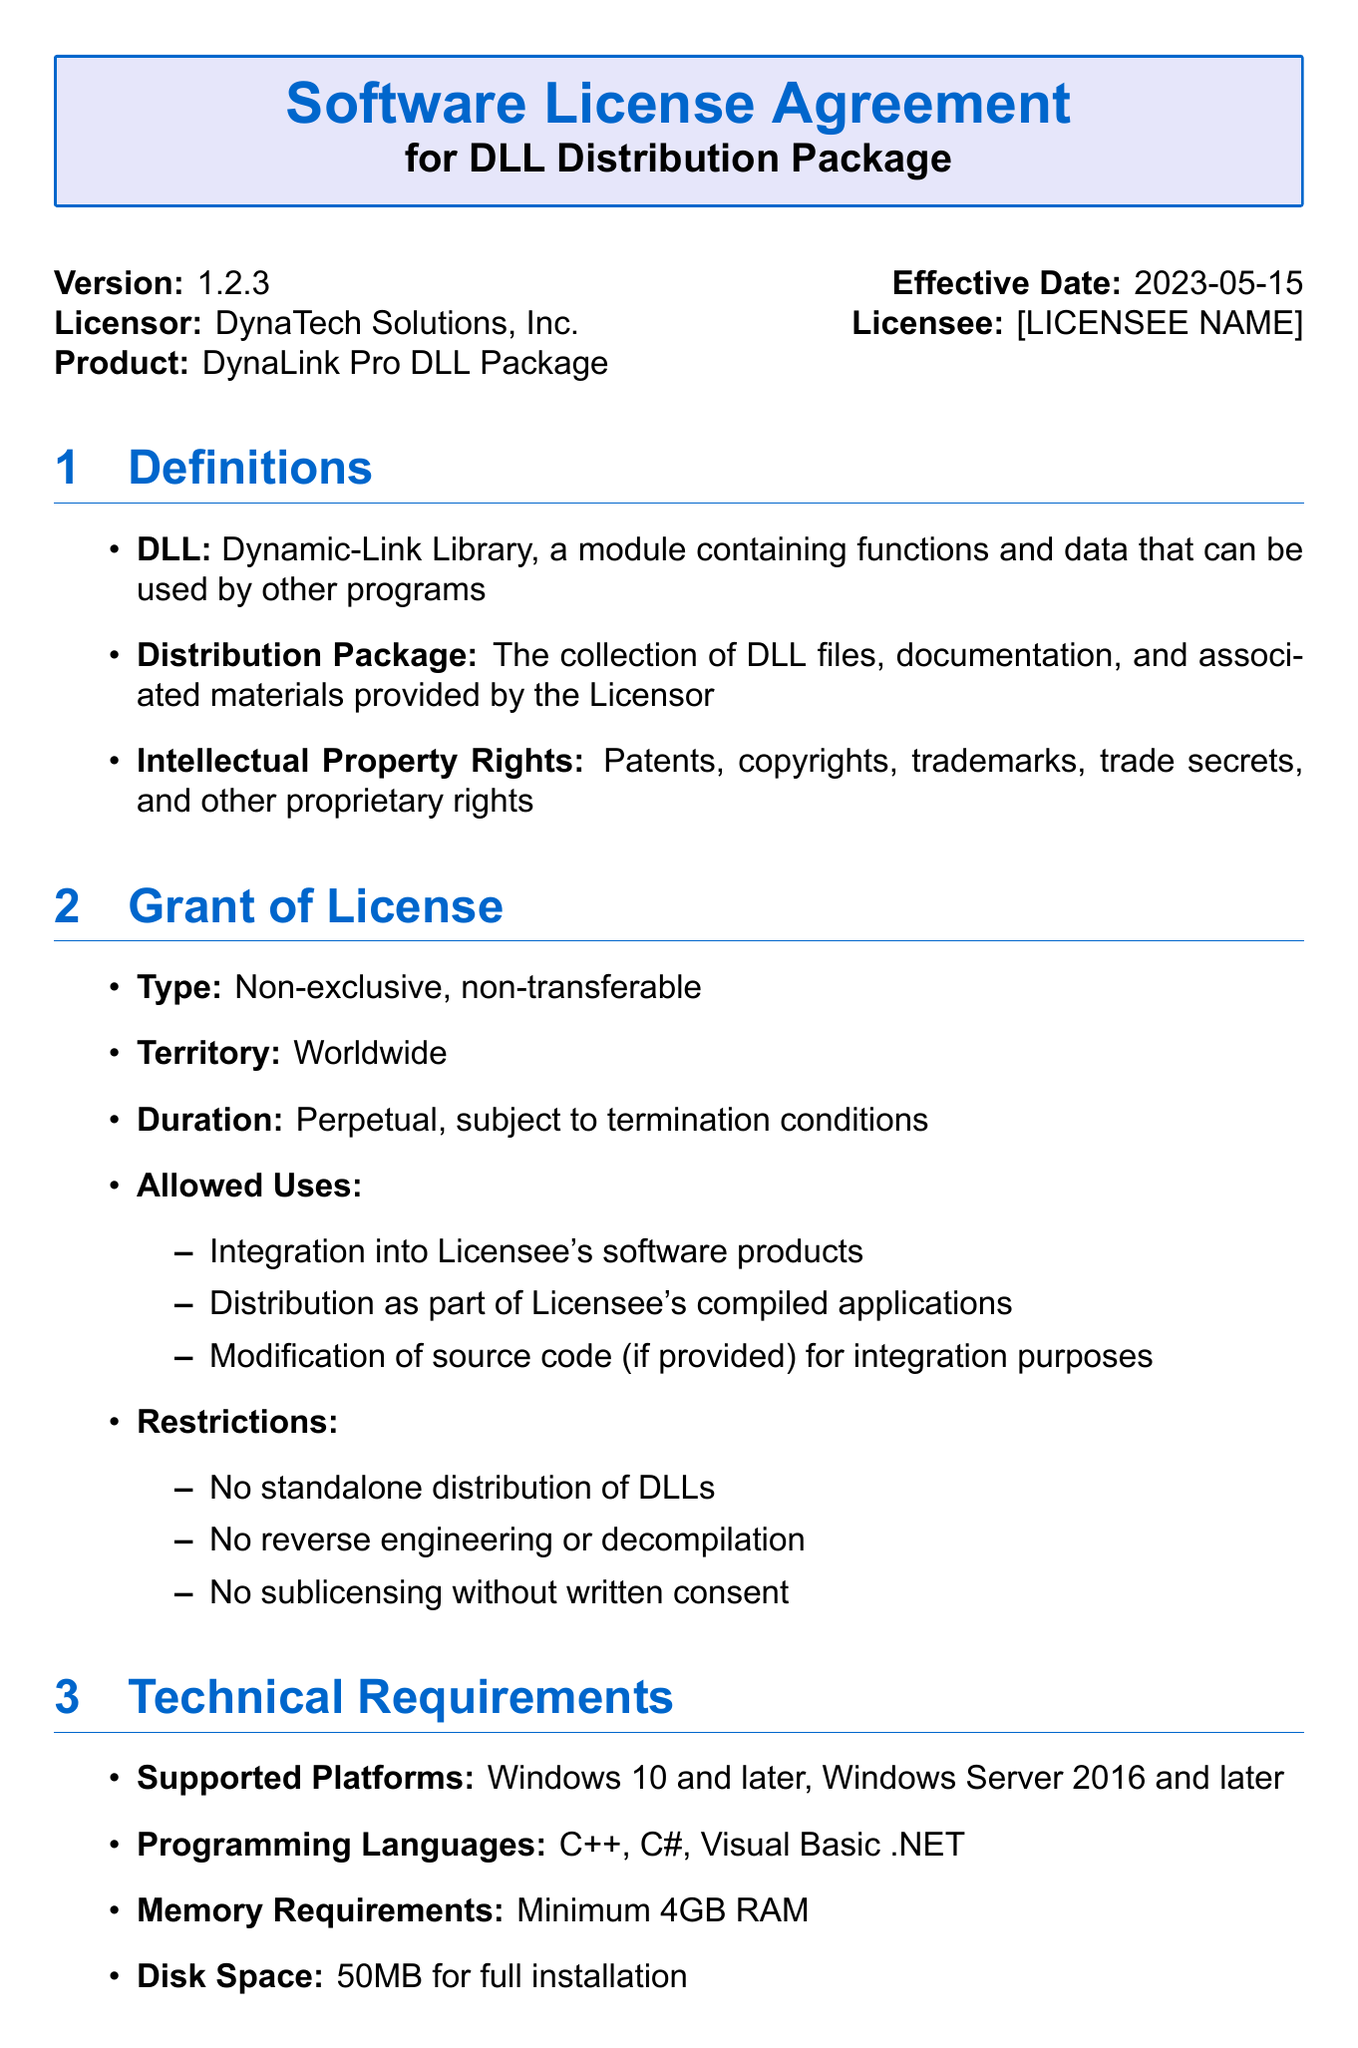What is the version of the license agreement? The version of the license agreement is mentioned towards the beginning of the document.
Answer: 1.2.3 What is the effective date of the agreement? The effective date is specified shortly after the version in the document.
Answer: 2023-05-15 Who is the licensor? The licensor is stated prominently at the start of the document.
Answer: DynaTech Solutions, Inc What are the allowed uses of the DLL? The allowed uses are detailed in the Grant of License section.
Answer: Integration into Licensee's software products, Distribution as part of Licensee's compiled applications, Modification of source code What are the restrictions placed on the licensee? The restrictions are listed under the Grant of License section, stating what the licensee cannot do.
Answer: No standalone distribution of DLLs, No reverse engineering or decompilation, No sublicensing without written consent What is the price of the Standard License? The price for this license type is clearly outlined in the Fees section of the document.
Answer: $2,500 per year How often are updates provided? The updates frequency is mentioned in the Maintenance and Support section.
Answer: Quarterly What happens upon termination by the licensee? The consequences of termination by the licensee are specified in the Termination section.
Answer: Cease all use of DLL package, Return or destroy all copies of DLL package, Certify compliance with termination obligations What is the governing law stated in the document? The governing law for this license agreement is mentioned in the governing law section.
Answer: State of California, United States 